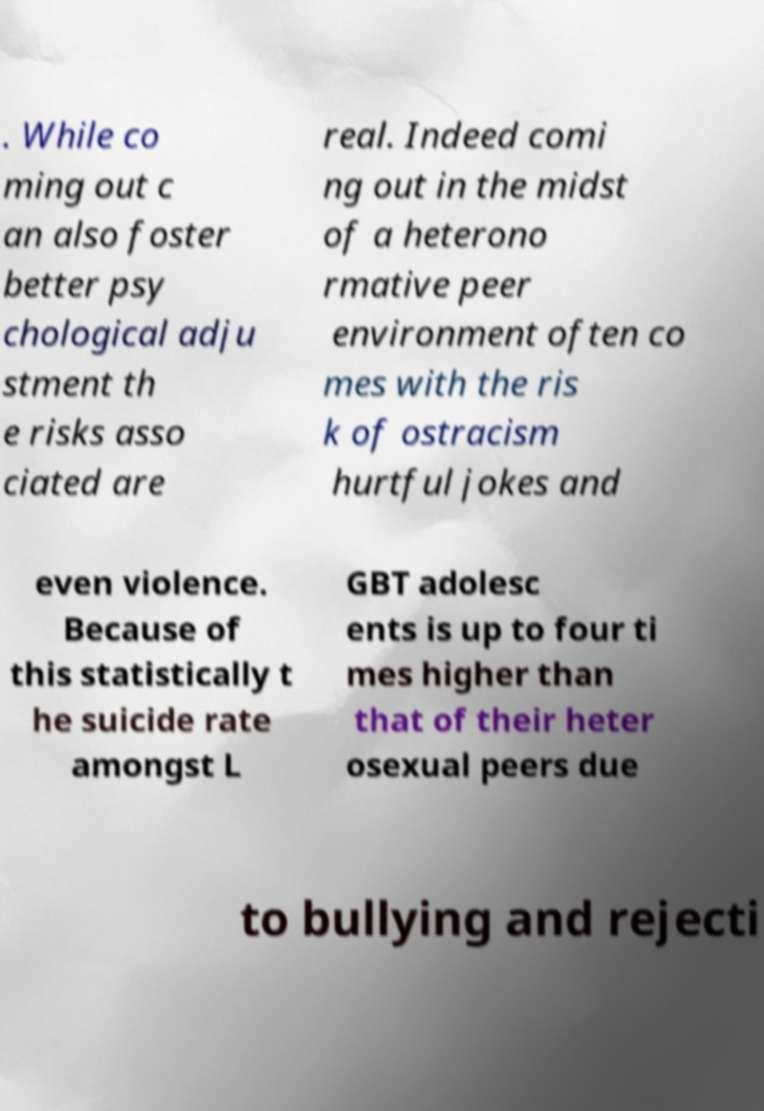Could you extract and type out the text from this image? . While co ming out c an also foster better psy chological adju stment th e risks asso ciated are real. Indeed comi ng out in the midst of a heterono rmative peer environment often co mes with the ris k of ostracism hurtful jokes and even violence. Because of this statistically t he suicide rate amongst L GBT adolesc ents is up to four ti mes higher than that of their heter osexual peers due to bullying and rejecti 